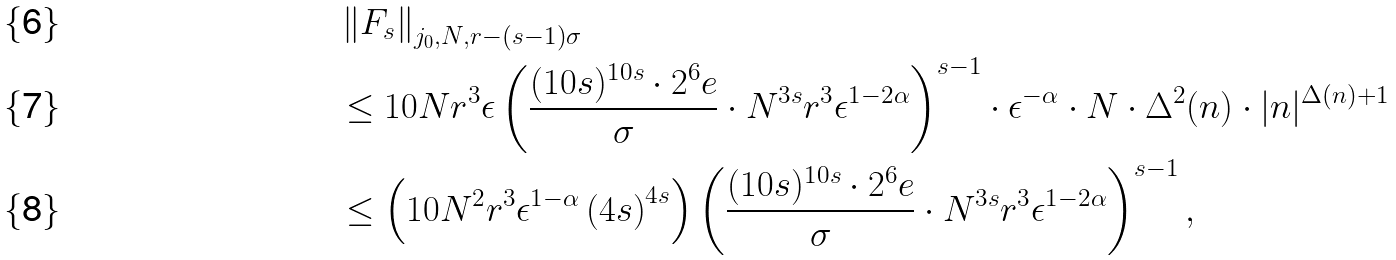Convert formula to latex. <formula><loc_0><loc_0><loc_500><loc_500>& \left \| F _ { s } \right \| _ { j _ { 0 } , N , r - ( s - 1 ) \sigma } \\ & \leq 1 0 N r ^ { 3 } \epsilon \left ( \frac { ( 1 0 s ) ^ { 1 0 s } \cdot 2 ^ { 6 } e } { \sigma } \cdot N ^ { 3 s } r ^ { 3 } \epsilon ^ { 1 - 2 \alpha } \right ) ^ { s - 1 } \cdot \epsilon ^ { - \alpha } \cdot { N } \cdot \Delta ^ { 2 } ( n ) \cdot | n | ^ { \Delta ( n ) + 1 } \\ & \leq \left ( 1 0 N ^ { 2 } r ^ { 3 } \epsilon ^ { 1 - \alpha } \left ( 4 s \right ) ^ { 4 s } \right ) \left ( \frac { ( 1 0 s ) ^ { 1 0 s } \cdot 2 ^ { 6 } e } { \sigma } \cdot N ^ { 3 s } r ^ { 3 } \epsilon ^ { 1 - 2 \alpha } \right ) ^ { s - 1 } ,</formula> 